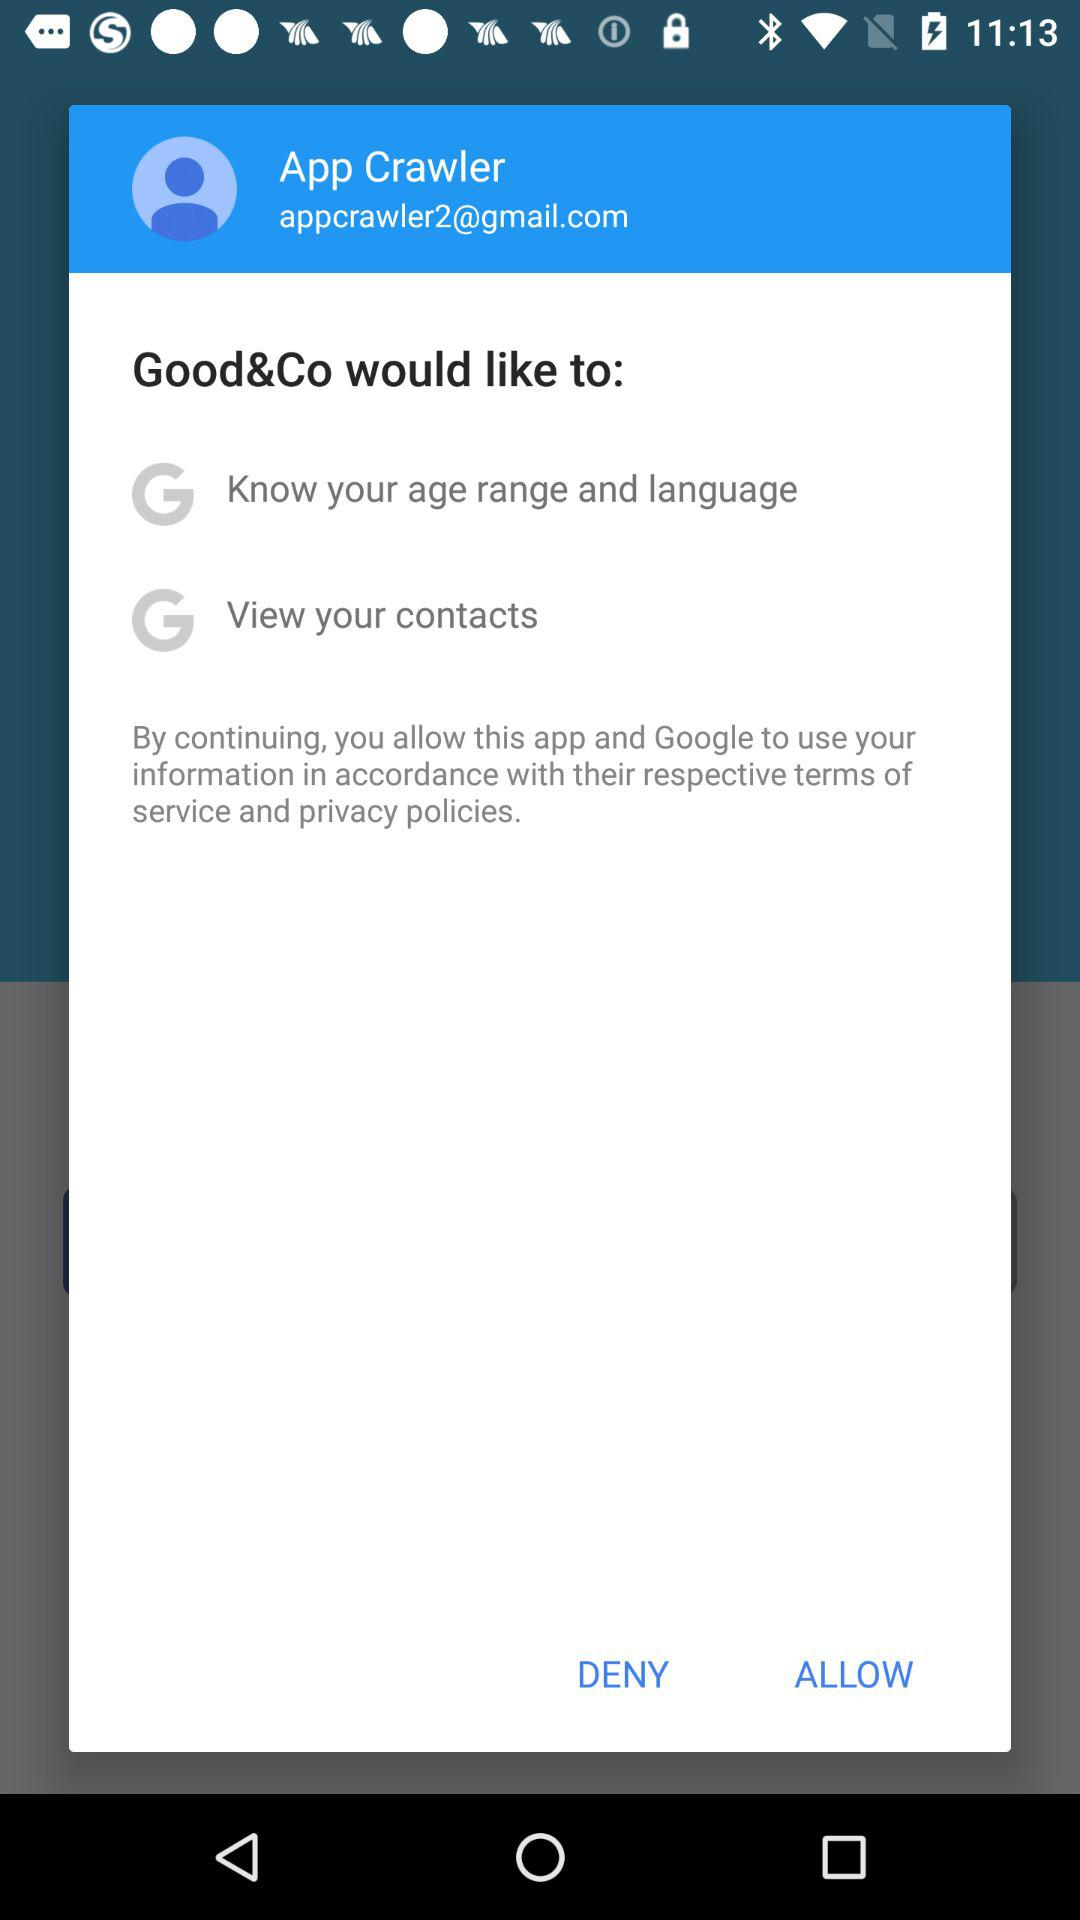How many permissions are requested by this app?
Answer the question using a single word or phrase. 2 